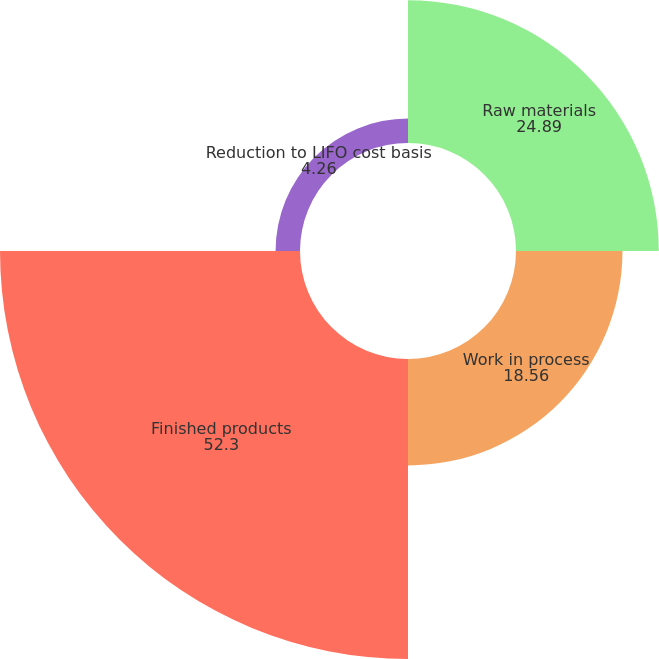Convert chart to OTSL. <chart><loc_0><loc_0><loc_500><loc_500><pie_chart><fcel>Raw materials<fcel>Work in process<fcel>Finished products<fcel>Reduction to LIFO cost basis<nl><fcel>24.89%<fcel>18.56%<fcel>52.3%<fcel>4.26%<nl></chart> 